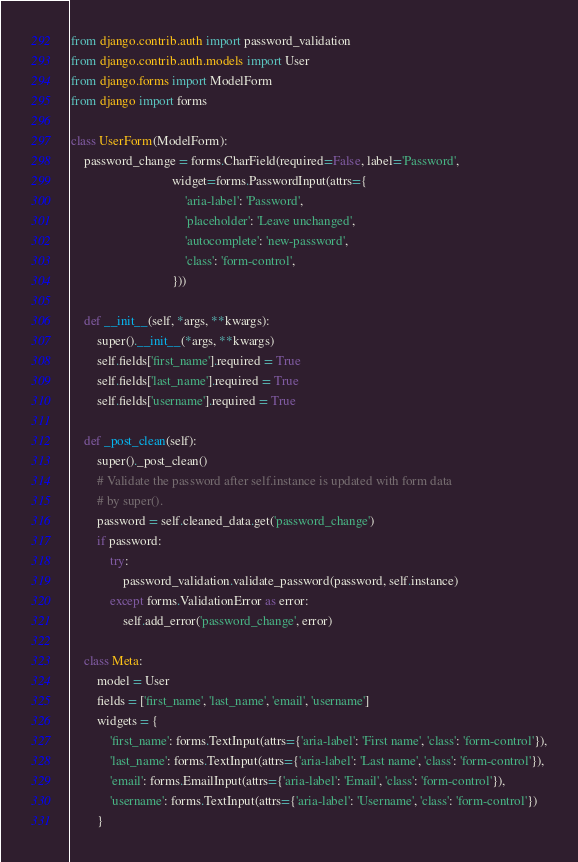<code> <loc_0><loc_0><loc_500><loc_500><_Python_>from django.contrib.auth import password_validation
from django.contrib.auth.models import User
from django.forms import ModelForm
from django import forms

class UserForm(ModelForm):
    password_change = forms.CharField(required=False, label='Password',
                               widget=forms.PasswordInput(attrs={
                                   'aria-label': 'Password',
                                   'placeholder': 'Leave unchanged',
                                   'autocomplete': 'new-password',
                                   'class': 'form-control',
                               }))

    def __init__(self, *args, **kwargs):
        super().__init__(*args, **kwargs)
        self.fields['first_name'].required = True
        self.fields['last_name'].required = True
        self.fields['username'].required = True

    def _post_clean(self):
        super()._post_clean()
        # Validate the password after self.instance is updated with form data
        # by super().
        password = self.cleaned_data.get('password_change')
        if password:
            try:
                password_validation.validate_password(password, self.instance)
            except forms.ValidationError as error:
                self.add_error('password_change', error)

    class Meta:
        model = User
        fields = ['first_name', 'last_name', 'email', 'username']
        widgets = {
            'first_name': forms.TextInput(attrs={'aria-label': 'First name', 'class': 'form-control'}),
            'last_name': forms.TextInput(attrs={'aria-label': 'Last name', 'class': 'form-control'}),
            'email': forms.EmailInput(attrs={'aria-label': 'Email', 'class': 'form-control'}),
            'username': forms.TextInput(attrs={'aria-label': 'Username', 'class': 'form-control'})
        }
</code> 